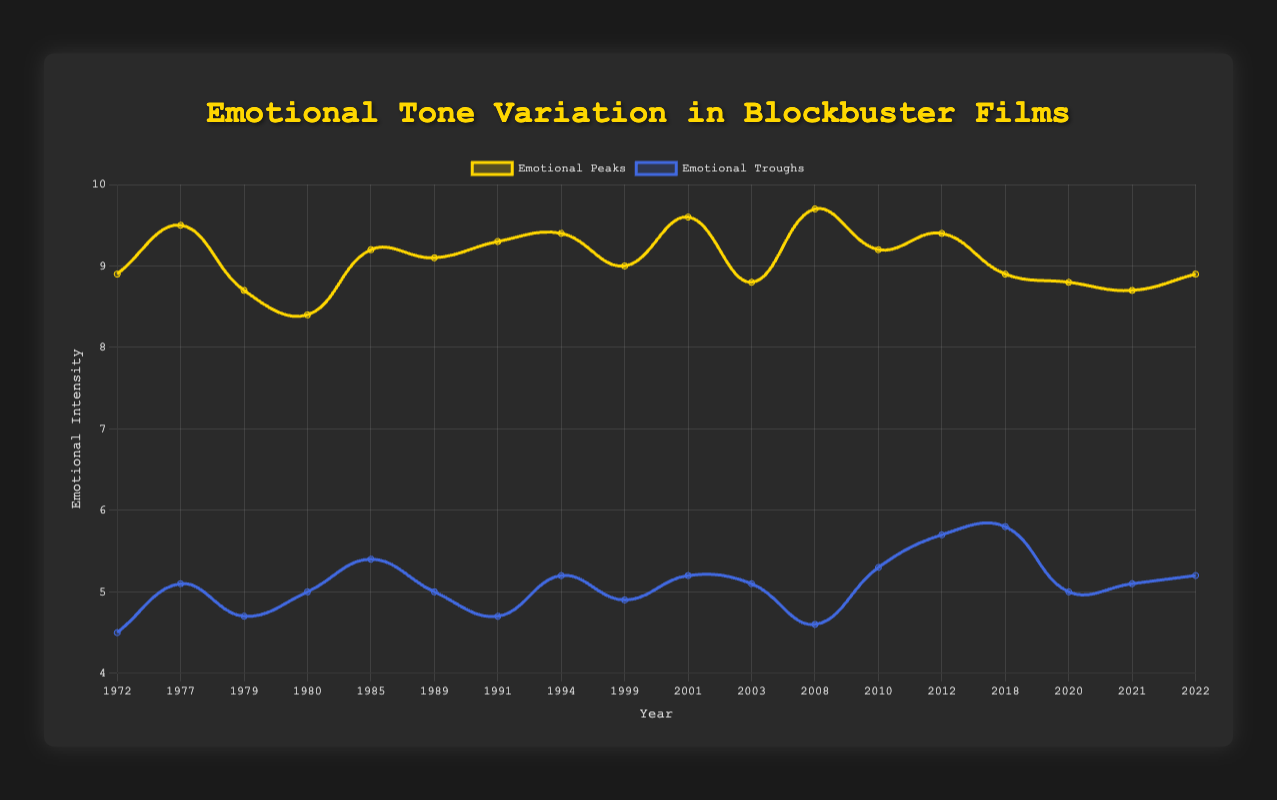What is the highest emotional peak depicted in the chart and which film does it correspond to? The highest emotional peak value on the chart is 9.7. This value corresponds to the film "The Dark Knight" released in 2008.
Answer: 9.7, "The Dark Knight" How does the emotional trough of "The Shining" (1980) compare to "The Dark Knight" (2008)? The emotional trough value for "The Shining" is 5.0, while for "The Dark Knight" it is 4.6. By comparing these values, "The Dark Knight" has a lower trough than "The Shining".
Answer: "The Dark Knight" has a lower trough Which decade shows the lowest average emotional trough across the films? To find the average emotional trough for each decade:
   - 1970s: (4.5 + 5.1 + 4.7) / 3 = 4.77
   - 1980s: (5.0 + 5.4 + 5.0) / 3 = 5.13
   - 1990s: (4.7 + 5.2 + 4.9) / 3 = 4.93
   - 2000s: (5.2 + 5.1 + 4.6) / 3 = 4.97
   - 2010s: (5.3 + 5.7 + 5.8) / 3 = 5.6
   - 2020s: (5.0 + 5.1 + 5.2) / 3 = 5.1
   So, the 1970s has the lowest average emotional trough of 4.77.
Answer: 1970s How does the emotional peak of "The Matrix" (1999) compare to the overall average peak of films in the 1990s? The emotional peak for "The Matrix" is 9.0. The average peak for films in the 1990s is:
   - (9.3 + 9.4 + 9.0) / 3 = 9.23
   Hence, "The Matrix" has an emotional peak lower than the average peak of the 1990s films.
Answer: 9.0 is lower than 9.23 Which film shows a relatively stable emotional tone, having both peak and trough values closer to each other? To determine stability, look for the smallest difference between peaks and troughs for each film. The smallest differences are:
   - "Indiana Jones and the Last Crusade": 9.1 - 5.0 = 4.1
   - "Finding Nemo": 8.8 - 5.1 = 3.7
   - "Black Panther": 8.9 - 5.8 = 3.1
   - "No Time to Die": 8.9 - 5.2 = 3.7
   So, "Black Panther" shows the most stable emotional tone, with a difference of 3.1 points.
Answer: "Black Panther" What is the difference in the emotional peak values between "The Godfather" (1972) and "Apocalypse Now" (1979)? The emotional peak value for "The Godfather" is 8.9, and for "Apocalypse Now" it is 8.7. The difference between these values is 0.2.
Answer: 0.2 Considering the data, which film from the 1980s marks the highest emotional peak? Looking at the emotional peak values for the 1980s:
   - "The Shining": 8.4
   - "Back to the Future": 9.2
   - "Indiana Jones and the Last Crusade": 9.1
   "Back to the Future" has the highest emotional peak of 9.2 among the 1980s films.
Answer: "Back to the Future", 9.2 